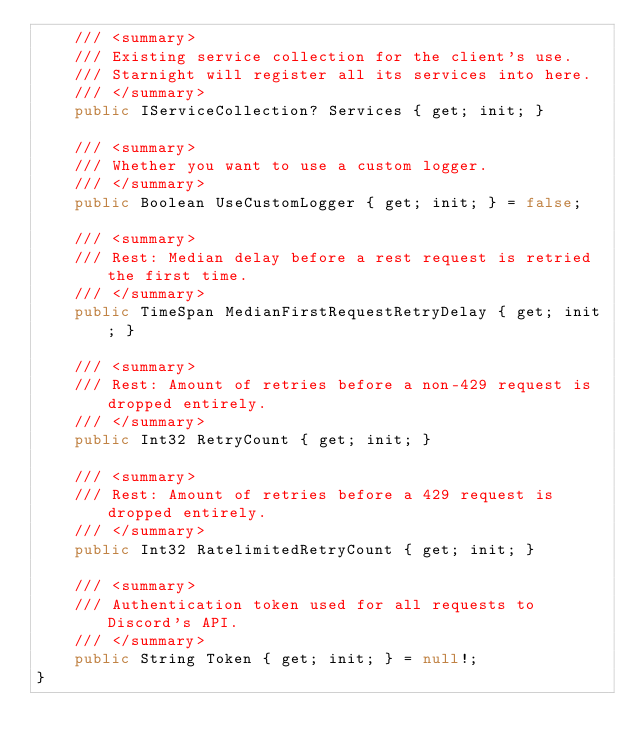Convert code to text. <code><loc_0><loc_0><loc_500><loc_500><_C#_>	/// <summary>
	/// Existing service collection for the client's use.
	/// Starnight will register all its services into here.
	/// </summary>
	public IServiceCollection? Services { get; init; }

	/// <summary>
	/// Whether you want to use a custom logger.
	/// </summary>
	public Boolean UseCustomLogger { get; init; } = false;

	/// <summary>
	/// Rest: Median delay before a rest request is retried the first time.
	/// </summary>
	public TimeSpan MedianFirstRequestRetryDelay { get; init; }

	/// <summary>
	/// Rest: Amount of retries before a non-429 request is dropped entirely.
	/// </summary>
	public Int32 RetryCount { get; init; }

	/// <summary>
	/// Rest: Amount of retries before a 429 request is dropped entirely.
	/// </summary>
	public Int32 RatelimitedRetryCount { get; init; }

	/// <summary>
	/// Authentication token used for all requests to Discord's API.
	/// </summary>
	public String Token { get; init; } = null!;
}
</code> 